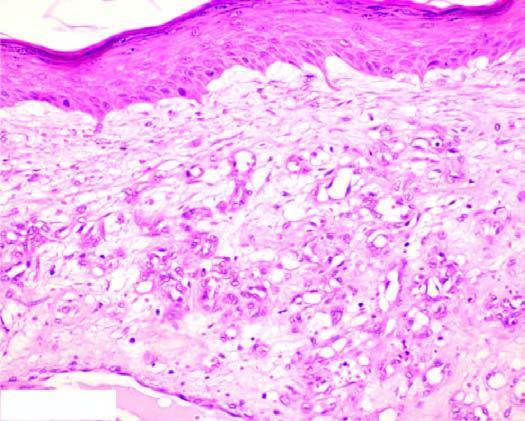re the sequence on left capillaries lined by plump endothelial cells and containing blood?
Answer the question using a single word or phrase. No 